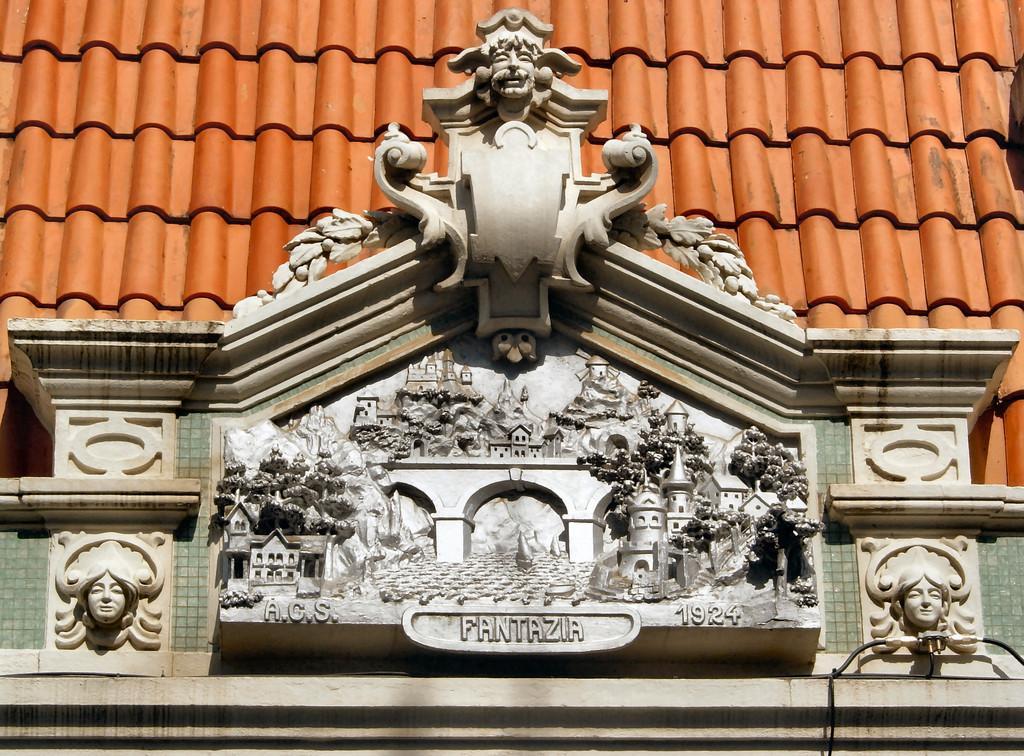In one or two sentences, can you explain what this image depicts? There is a carving and roof of a building. 